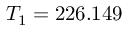Convert formula to latex. <formula><loc_0><loc_0><loc_500><loc_500>T _ { 1 } = 2 2 6 . 1 4 9</formula> 